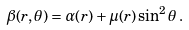Convert formula to latex. <formula><loc_0><loc_0><loc_500><loc_500>\beta ( r , \theta ) = \alpha ( r ) + \mu ( r ) \sin ^ { 2 } \theta \, .</formula> 